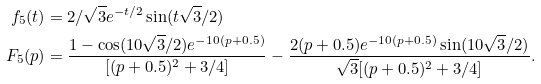<formula> <loc_0><loc_0><loc_500><loc_500>f _ { 5 } ( t ) & = 2 / \sqrt { 3 } e ^ { - t / 2 } \sin ( t \sqrt { 3 } / 2 ) \\ F _ { 5 } ( p ) & = \frac { 1 - \cos ( 1 0 \sqrt { 3 } / 2 ) e ^ { - 1 0 ( p + 0 . 5 ) } } { [ ( p + 0 . 5 ) ^ { 2 } + 3 / 4 ] } - \frac { 2 ( p + 0 . 5 ) e ^ { - 1 0 ( p + 0 . 5 ) } \sin ( 1 0 \sqrt { 3 } / 2 ) } { \sqrt { 3 } [ ( p + 0 . 5 ) ^ { 2 } + 3 / 4 ] } .</formula> 